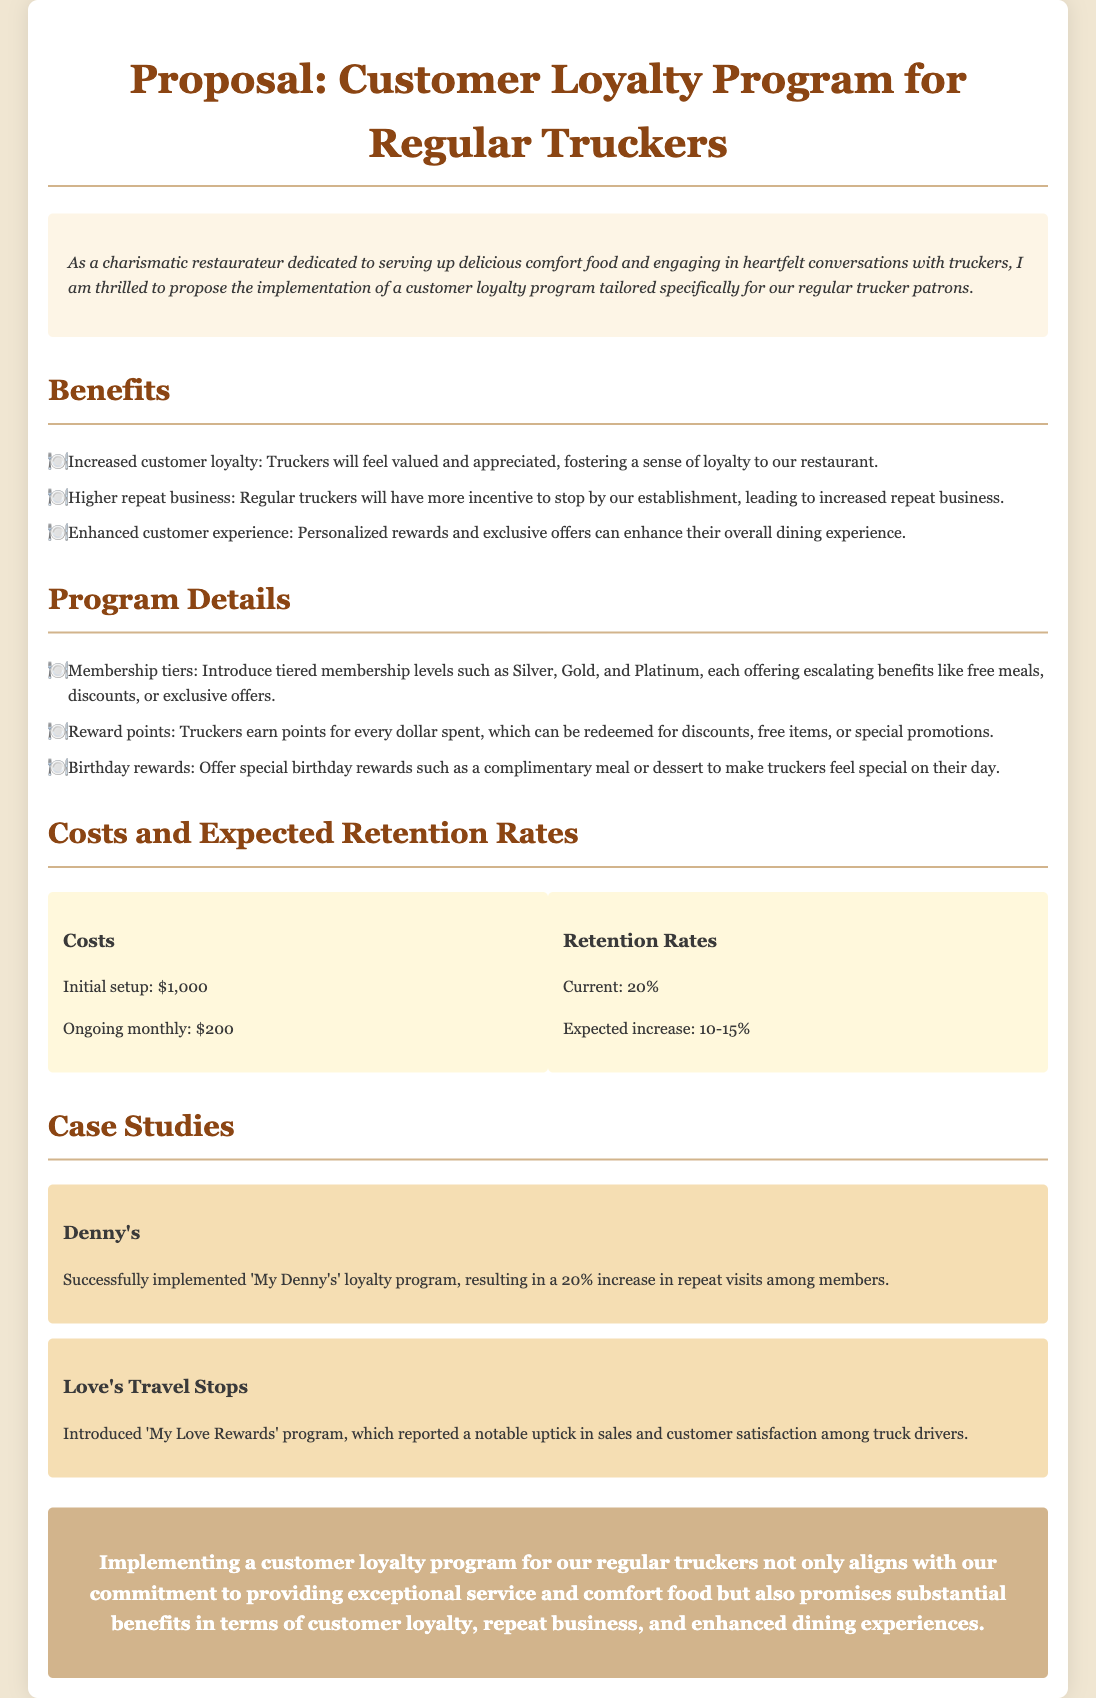What are the membership tiers proposed? The document outlines three membership tiers: Silver, Gold, and Platinum.
Answer: Silver, Gold, Platinum What is the initial setup cost for the loyalty program? The initial setup cost mentioned in the document is $1,000.
Answer: $1,000 What is the current customer retention rate stated? The current retention rate mentioned in the proposal is 20%.
Answer: 20% How much does the document estimate the ongoing monthly costs to be? The ongoing monthly costs are stated as $200.
Answer: $200 What special reward is offered for truckers' birthdays? The proposal mentions offering a complimentary meal or dessert as a birthday reward.
Answer: Complimentary meal or dessert What increase in retention rates is expected from the loyalty program? The expected increase in retention rates is between 10-15%.
Answer: 10-15% Which restaurant successfully implemented a loyalty program according to the document? Denny's is mentioned as a successful implementer of a loyalty program.
Answer: Denny's What is the main purpose of the proposed loyalty program? The main purpose is to increase customer loyalty and repeat business for regular truckers.
Answer: Increase customer loyalty and repeat business What is listed as one of the program benefits? One benefit mentioned is enhanced customer experience.
Answer: Enhanced customer experience 